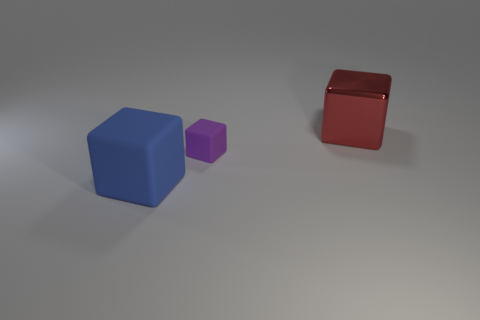Add 3 blocks. How many objects exist? 6 Subtract all large blue shiny balls. Subtract all large metallic blocks. How many objects are left? 2 Add 3 rubber cubes. How many rubber cubes are left? 5 Add 3 large gray cubes. How many large gray cubes exist? 3 Subtract 0 gray cylinders. How many objects are left? 3 